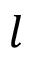Convert formula to latex. <formula><loc_0><loc_0><loc_500><loc_500>l</formula> 